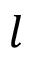Convert formula to latex. <formula><loc_0><loc_0><loc_500><loc_500>l</formula> 